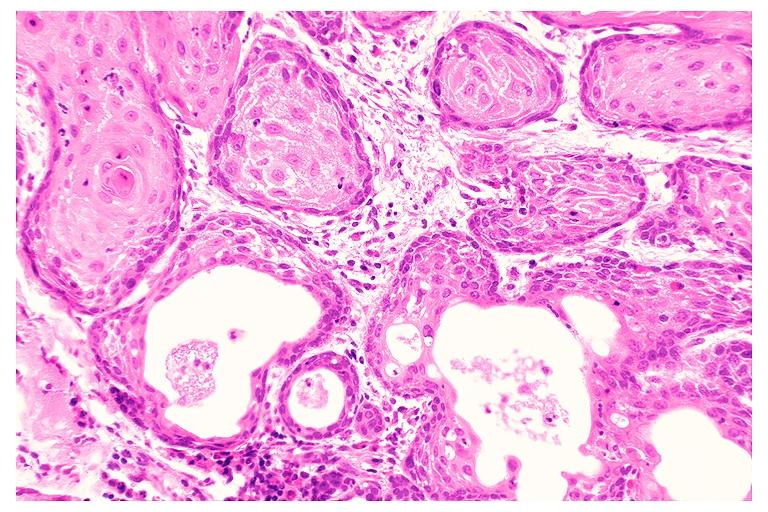does this image show necrotizing sialometaplasia?
Answer the question using a single word or phrase. Yes 